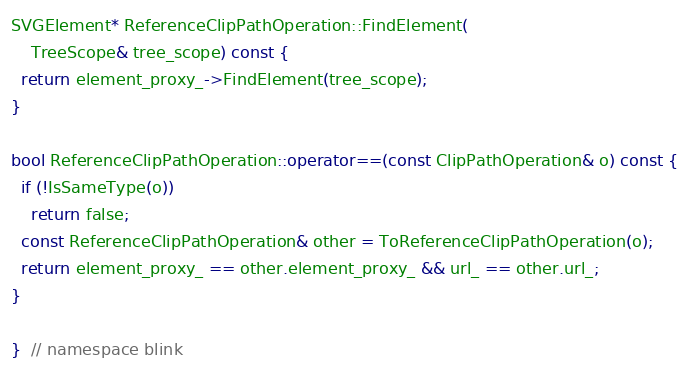Convert code to text. <code><loc_0><loc_0><loc_500><loc_500><_C++_>SVGElement* ReferenceClipPathOperation::FindElement(
    TreeScope& tree_scope) const {
  return element_proxy_->FindElement(tree_scope);
}

bool ReferenceClipPathOperation::operator==(const ClipPathOperation& o) const {
  if (!IsSameType(o))
    return false;
  const ReferenceClipPathOperation& other = ToReferenceClipPathOperation(o);
  return element_proxy_ == other.element_proxy_ && url_ == other.url_;
}

}  // namespace blink
</code> 